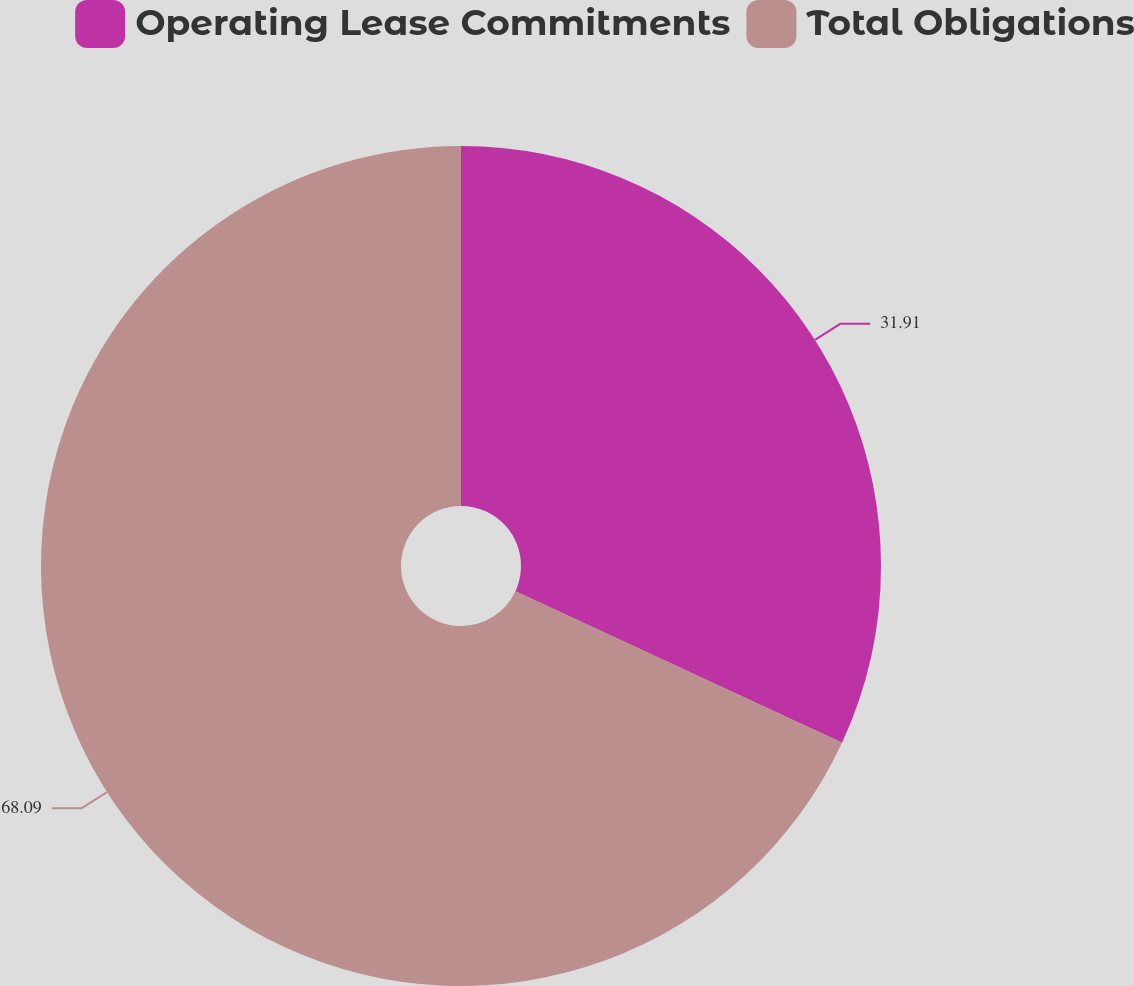<chart> <loc_0><loc_0><loc_500><loc_500><pie_chart><fcel>Operating Lease Commitments<fcel>Total Obligations<nl><fcel>31.91%<fcel>68.09%<nl></chart> 